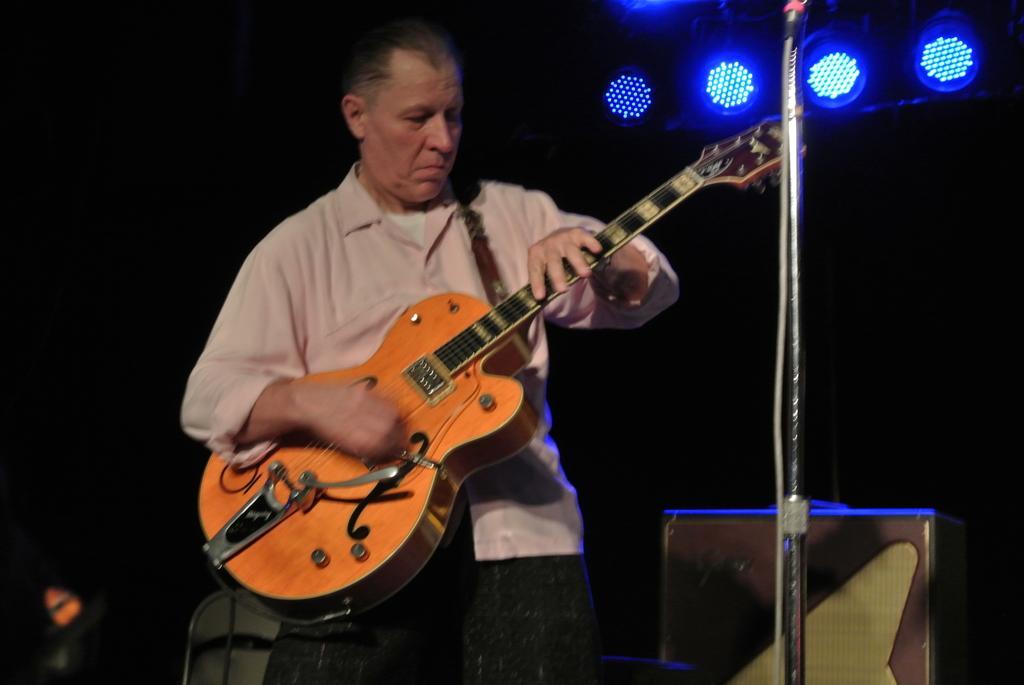In one or two sentences, can you explain what this image depicts? Here we can see that a person is standing and holding a guitar in his hand, and at side her is the stand, and at back here are the lights. 